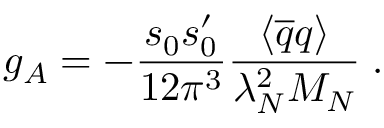<formula> <loc_0><loc_0><loc_500><loc_500>g _ { A } = - \frac { s _ { 0 } s _ { 0 } ^ { \prime } } { 1 2 \pi ^ { 3 } } \frac { \langle \overline { q } q \rangle } { \lambda _ { N } ^ { 2 } M _ { N } } \, . \,</formula> 